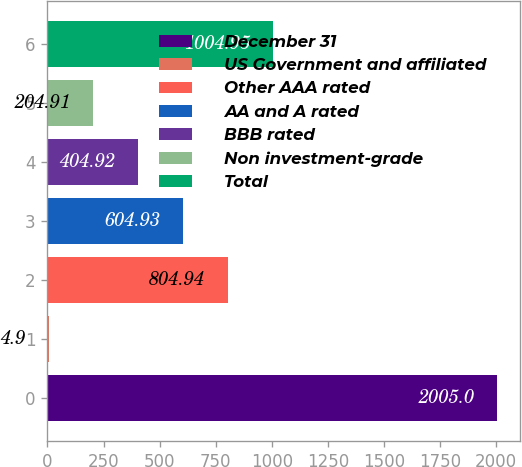Convert chart to OTSL. <chart><loc_0><loc_0><loc_500><loc_500><bar_chart><fcel>December 31<fcel>US Government and affiliated<fcel>Other AAA rated<fcel>AA and A rated<fcel>BBB rated<fcel>Non investment-grade<fcel>Total<nl><fcel>2005<fcel>4.9<fcel>804.94<fcel>604.93<fcel>404.92<fcel>204.91<fcel>1004.95<nl></chart> 